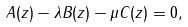<formula> <loc_0><loc_0><loc_500><loc_500>A ( z ) - \lambda B ( z ) - \mu C ( z ) = 0 ,</formula> 